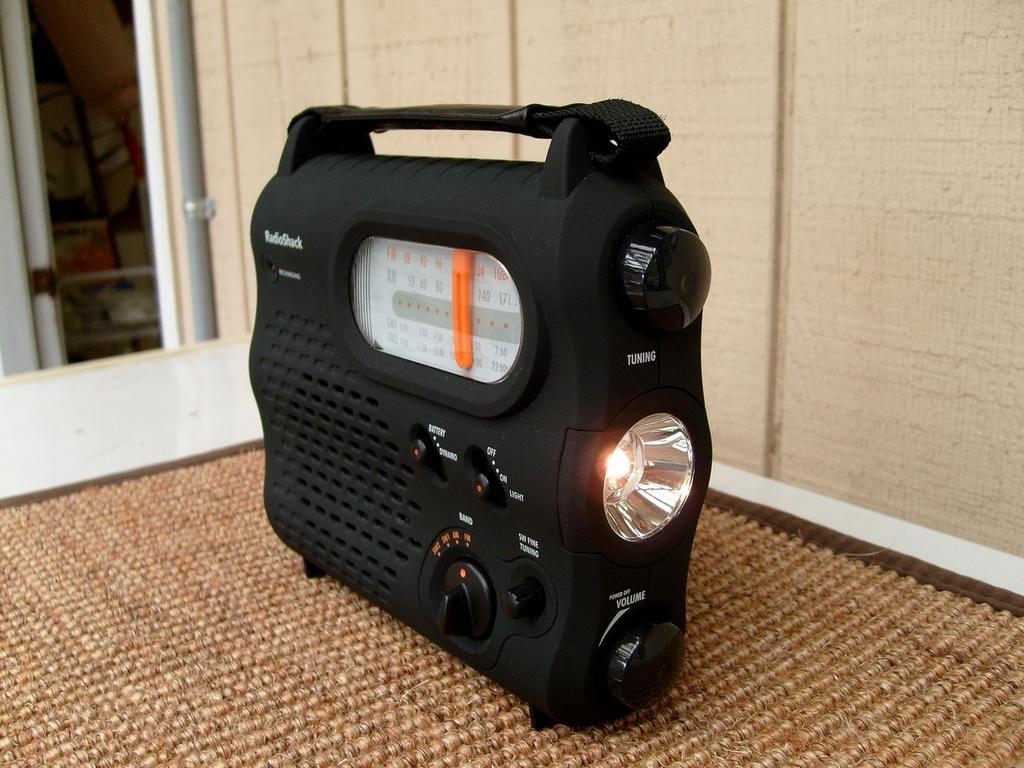In one or two sentences, can you explain what this image depicts? There is a radio having tuners, buttons, speaker and a light, on a mat which is on the table. In the background, there is a pipe and there is wall. 